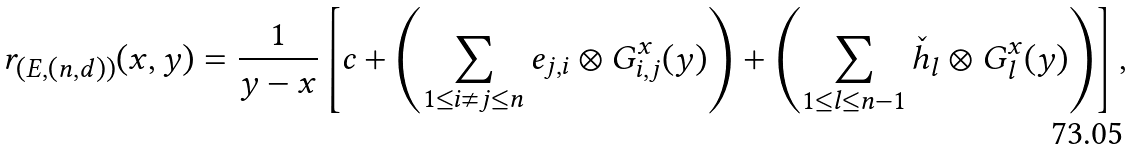<formula> <loc_0><loc_0><loc_500><loc_500>r _ { ( E , ( n , d ) ) } ( x , y ) = \frac { 1 } { y - x } \left [ c + \left ( \sum _ { 1 \leq i \ne j \leq n } e _ { j , i } \otimes G _ { i , j } ^ { x } ( y ) \right ) + \left ( \sum _ { 1 \leq l \leq n - 1 } \check { h } _ { l } \otimes G _ { l } ^ { x } ( y ) \right ) \right ] ,</formula> 